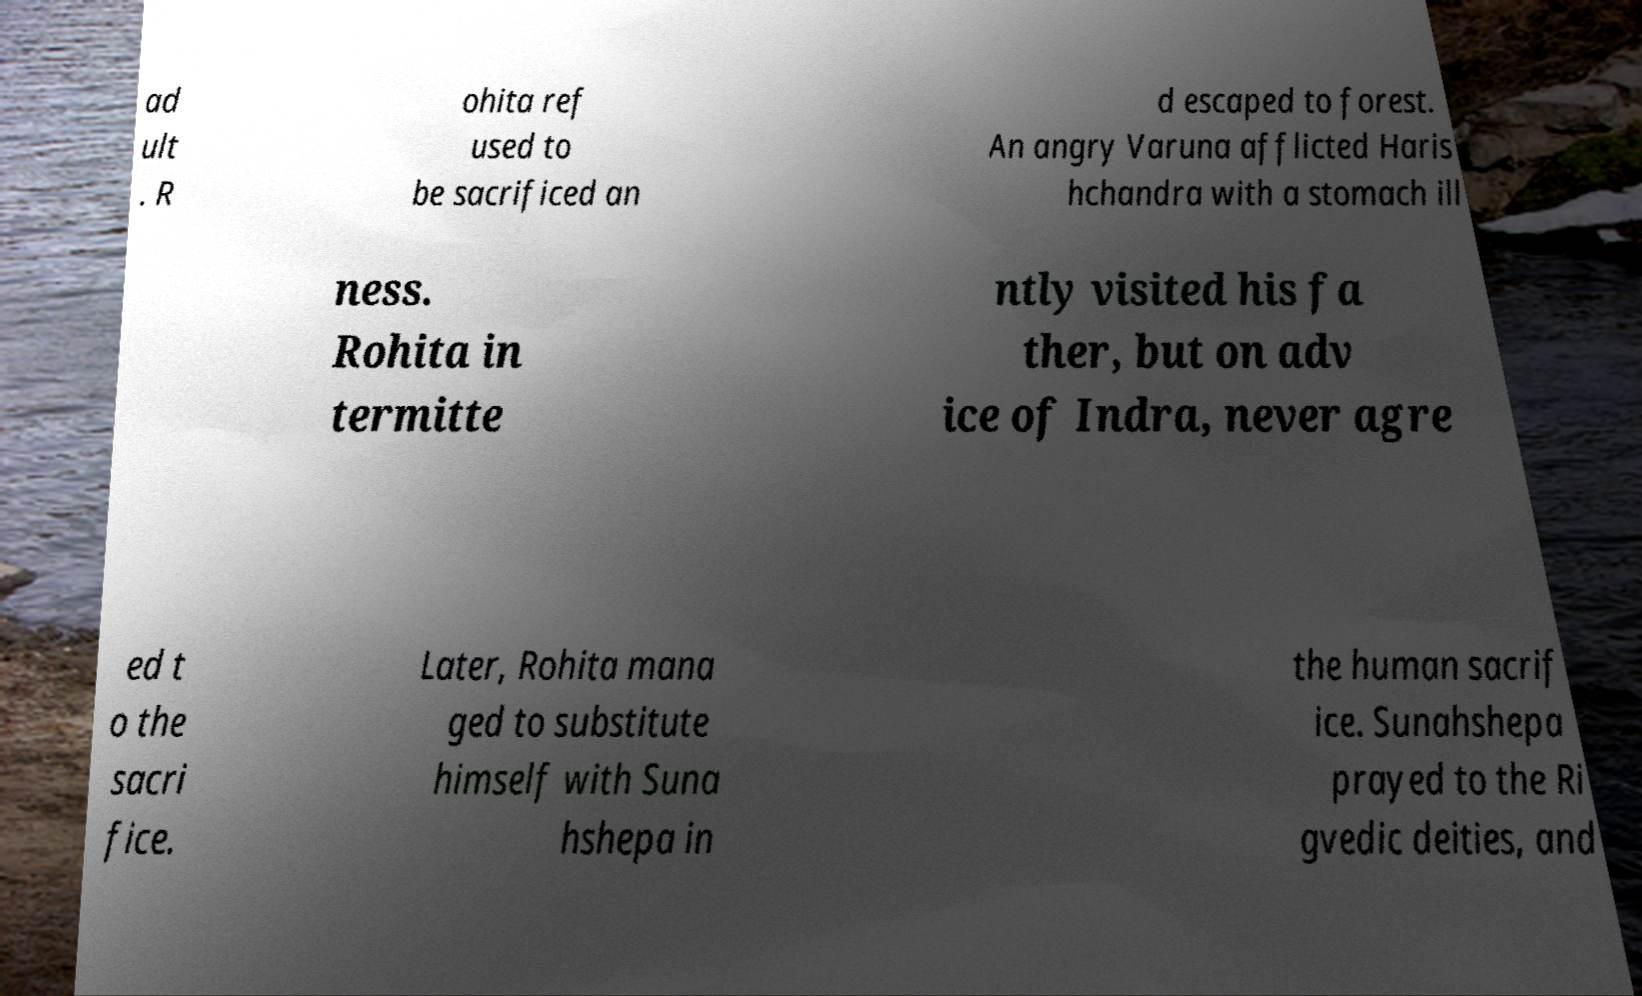Could you assist in decoding the text presented in this image and type it out clearly? ad ult . R ohita ref used to be sacrificed an d escaped to forest. An angry Varuna afflicted Haris hchandra with a stomach ill ness. Rohita in termitte ntly visited his fa ther, but on adv ice of Indra, never agre ed t o the sacri fice. Later, Rohita mana ged to substitute himself with Suna hshepa in the human sacrif ice. Sunahshepa prayed to the Ri gvedic deities, and 